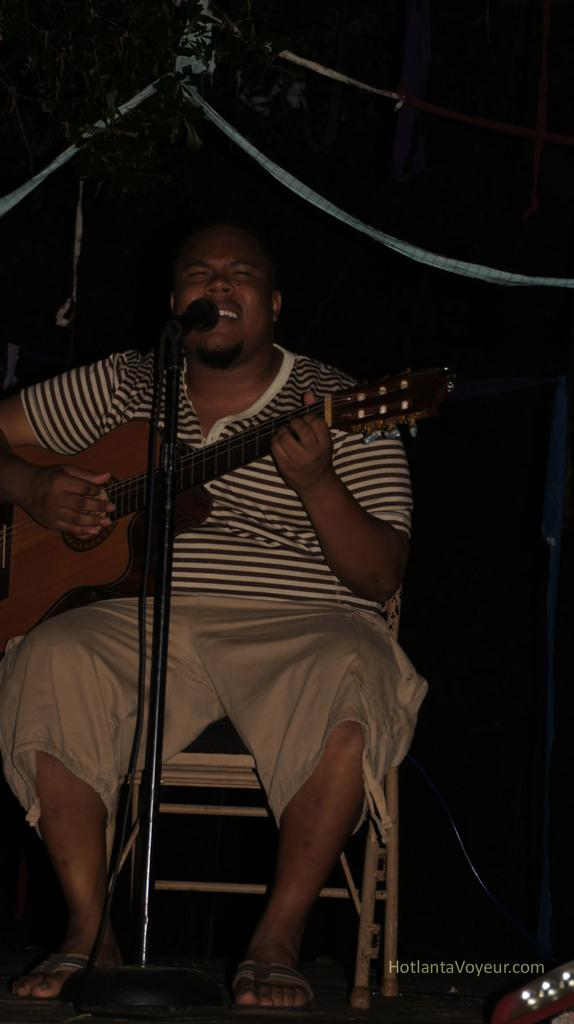What is the musician doing in the image? The musician is sitting on a chair, holding a guitar, playing the guitar, and singing. What instrument is the musician playing? The musician is playing a guitar. How is the microphone positioned in the image? The microphone is on a stand. What type of bridge can be seen in the background of the image? There is no bridge visible in the image. Is there a ghost playing the guitar alongside the musician in the image? No, there is no ghost present in the image. 